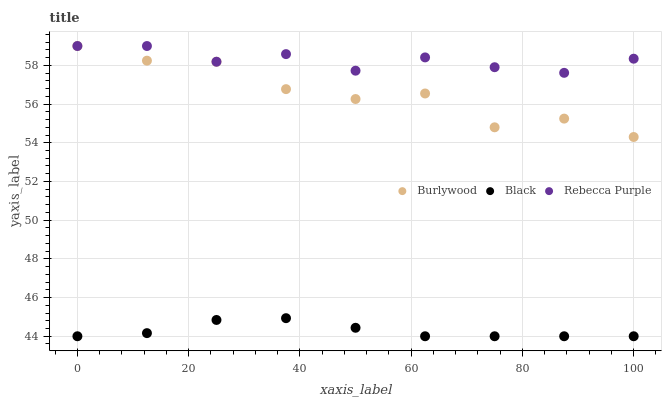Does Black have the minimum area under the curve?
Answer yes or no. Yes. Does Rebecca Purple have the maximum area under the curve?
Answer yes or no. Yes. Does Rebecca Purple have the minimum area under the curve?
Answer yes or no. No. Does Black have the maximum area under the curve?
Answer yes or no. No. Is Black the smoothest?
Answer yes or no. Yes. Is Burlywood the roughest?
Answer yes or no. Yes. Is Rebecca Purple the smoothest?
Answer yes or no. No. Is Rebecca Purple the roughest?
Answer yes or no. No. Does Black have the lowest value?
Answer yes or no. Yes. Does Rebecca Purple have the lowest value?
Answer yes or no. No. Does Rebecca Purple have the highest value?
Answer yes or no. Yes. Does Black have the highest value?
Answer yes or no. No. Is Black less than Rebecca Purple?
Answer yes or no. Yes. Is Rebecca Purple greater than Black?
Answer yes or no. Yes. Does Rebecca Purple intersect Burlywood?
Answer yes or no. Yes. Is Rebecca Purple less than Burlywood?
Answer yes or no. No. Is Rebecca Purple greater than Burlywood?
Answer yes or no. No. Does Black intersect Rebecca Purple?
Answer yes or no. No. 